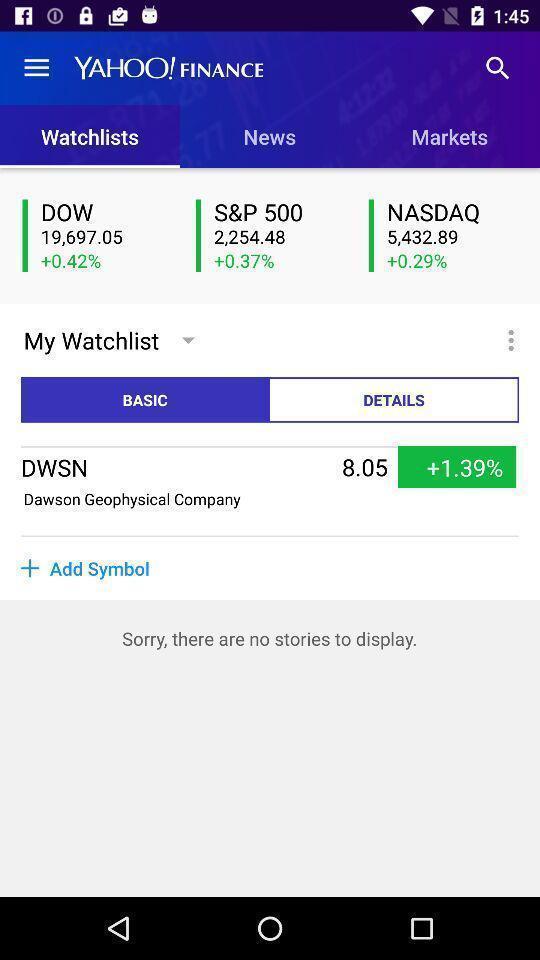Give me a narrative description of this picture. Screen displaying content in a financial application. 